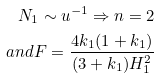<formula> <loc_0><loc_0><loc_500><loc_500>N _ { 1 } \sim u ^ { - 1 } \Rightarrow n = 2 \\ a n d F = \frac { 4 k _ { 1 } ( 1 + k _ { 1 } ) } { ( 3 + k _ { 1 } ) H _ { 1 } ^ { 2 } }</formula> 